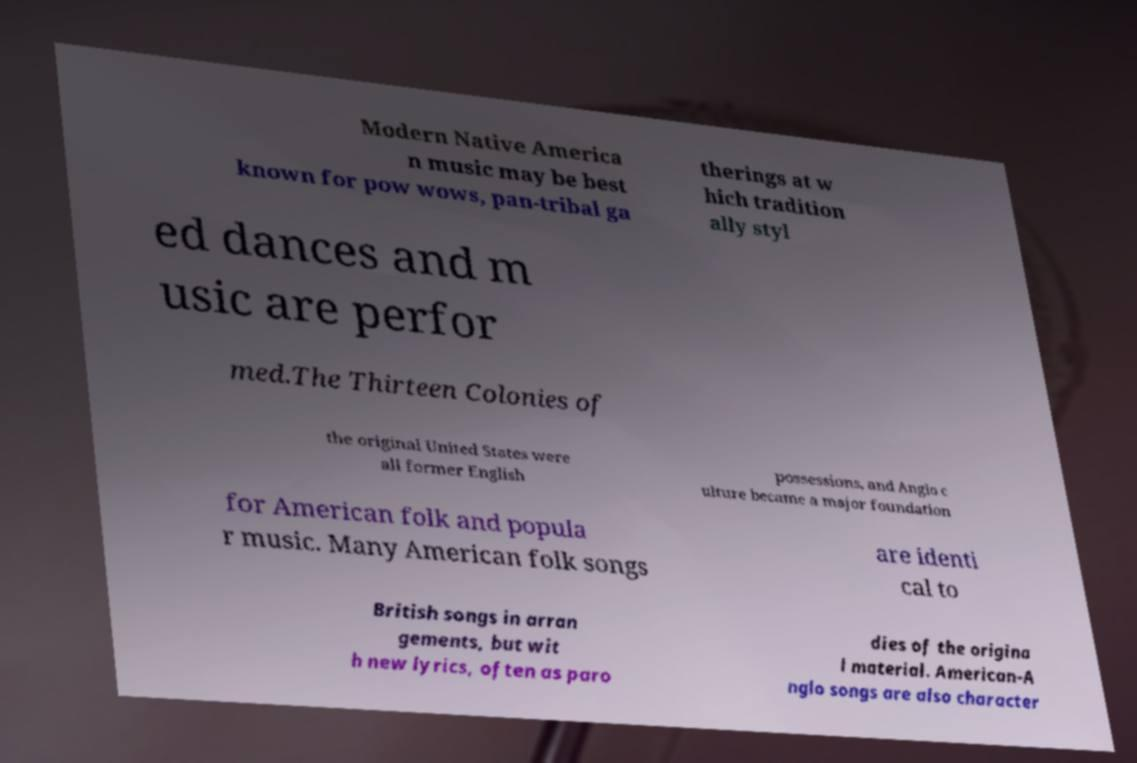Can you read and provide the text displayed in the image?This photo seems to have some interesting text. Can you extract and type it out for me? Modern Native America n music may be best known for pow wows, pan-tribal ga therings at w hich tradition ally styl ed dances and m usic are perfor med.The Thirteen Colonies of the original United States were all former English possessions, and Anglo c ulture became a major foundation for American folk and popula r music. Many American folk songs are identi cal to British songs in arran gements, but wit h new lyrics, often as paro dies of the origina l material. American-A nglo songs are also character 